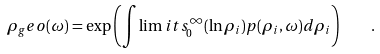<formula> <loc_0><loc_0><loc_500><loc_500>\rho _ { g } e o ( \omega ) = \exp \left ( \int \lim i t s _ { 0 } ^ { \infty } ( \ln \rho _ { i } ) p ( \rho _ { i } , \omega ) d \rho _ { i } \right ) \quad .</formula> 